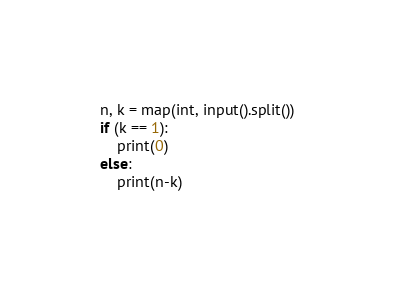<code> <loc_0><loc_0><loc_500><loc_500><_Python_>n, k = map(int, input().split())
if (k == 1):
    print(0)
else:
    print(n-k)
</code> 